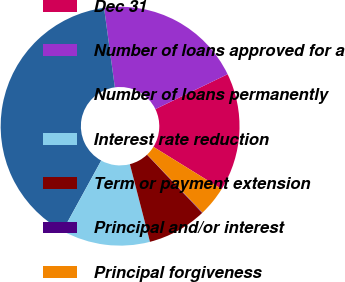Convert chart. <chart><loc_0><loc_0><loc_500><loc_500><pie_chart><fcel>Dec 31<fcel>Number of loans approved for a<fcel>Number of loans permanently<fcel>Interest rate reduction<fcel>Term or payment extension<fcel>Principal and/or interest<fcel>Principal forgiveness<nl><fcel>15.99%<fcel>19.97%<fcel>39.87%<fcel>12.01%<fcel>8.03%<fcel>0.07%<fcel>4.05%<nl></chart> 